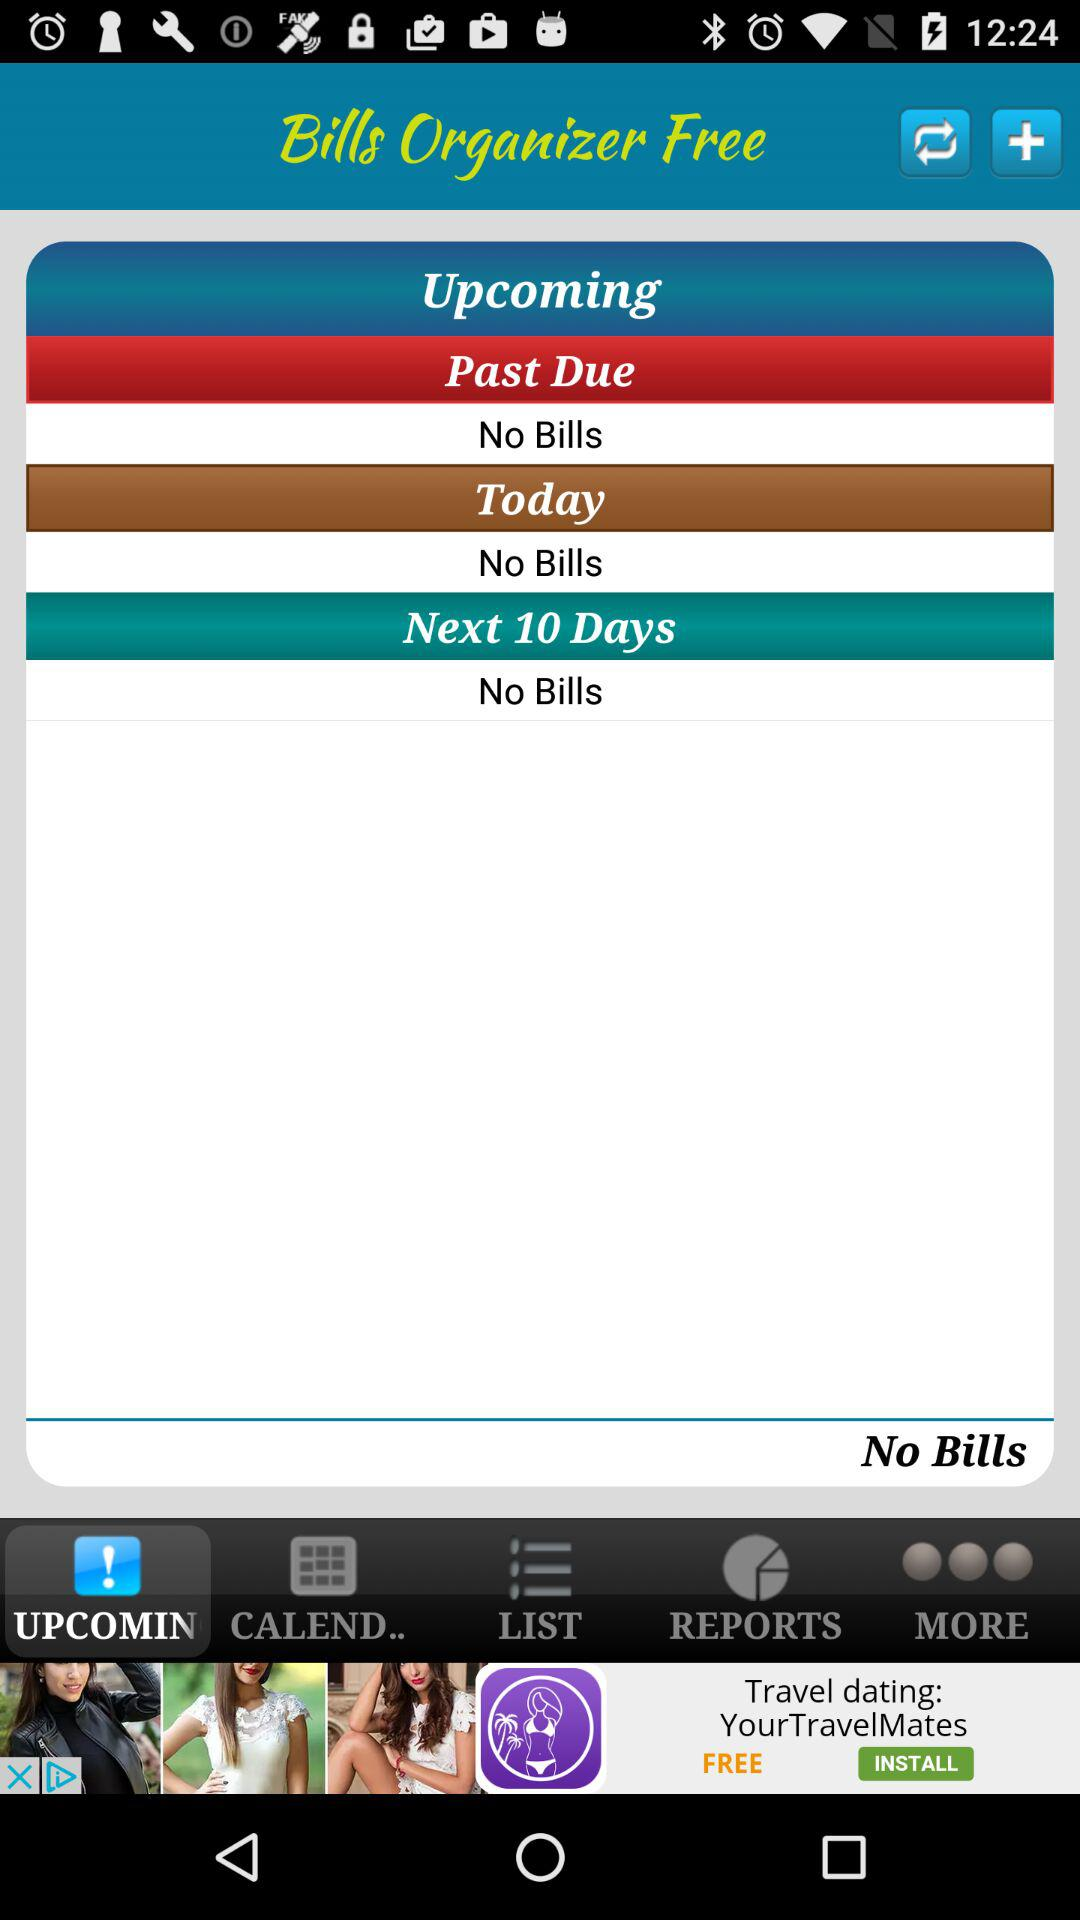How many bills are past due?
Answer the question using a single word or phrase. 0 